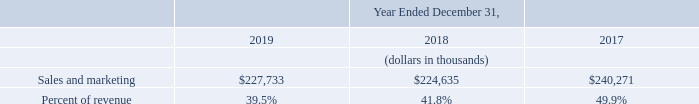Sales and Marketing
Sales and marketing expenses increased $3.1 million, or 1%, in 2019 as compared to 2018. As a percentage of revenue, sales and marketing expense decreased by approximately two percentage points, resulting from the 2018 Reallocation, increased cost efficiency, and leverage realized from changes to our sales commission plans as we continued our efforts to strategically scale our sales teams and improve their productivity.
Sales and marketing expenses decreased $15.6 million, or 7%, in 2018 as compared to 2017. As a percentage of revenue, sales and marketing expense decreased by approximately eight percentage points, primarily resulting from a combination of increased cost efficiency, reduction in headcount as part of our restructuring activities, and leverage realized from changes to our sales commission plans as we continued our efforts to strategically scale our sales teams and improve their productivity.
Why did sales and marketing expenses increase between 2018 and 2019? The 2018 reallocation, increased cost efficiency, and leverage realized from changes to our sales commission plans as we continued our efforts to strategically scale our sales teams and improve their productivity. What was the sales and marketing expense in 2017?
Answer scale should be: thousand. $240,271. What was the sales and marketing expense in 2018?
Answer scale should be: thousand. $224,635. What is the change in sales and marketing between 2018 and 2019?
Answer scale should be: thousand. ($227,733-$224,635)
Answer: 3098. What was the average sales and marketing expense from 2017-2019?
Answer scale should be: thousand. ($227,733+$224,635+$240,271)/(2019-2017+1)
Answer: 230879.67. What was the change in percent of revenue between 2018 and 2019?
Answer scale should be: percent. (39.5%-41.8%)
Answer: -2.3. 